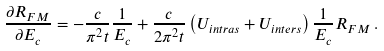Convert formula to latex. <formula><loc_0><loc_0><loc_500><loc_500>\frac { \partial R _ { F M } } { \partial E _ { c } } = - \frac { c } { \pi ^ { 2 } t } \frac { 1 } { E _ { c } } + \frac { c } { 2 \pi ^ { 2 } t } \left ( U _ { i n t r a s } + U _ { i n t e r s } \right ) \frac { 1 } { E _ { c } } R _ { F M } \, .</formula> 